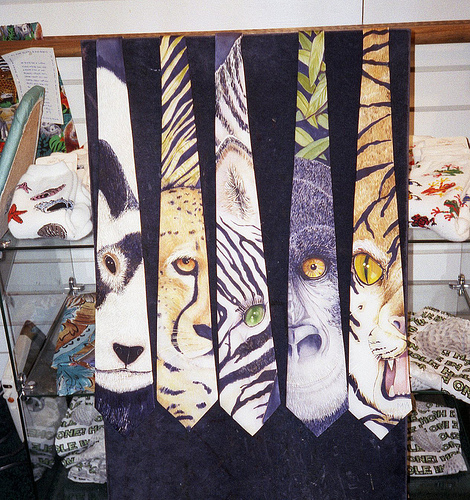Do you see both ties and glasses? Yes, there are multiple ties uniquely designed with animal prints, but there are no glasses visible in the image. 